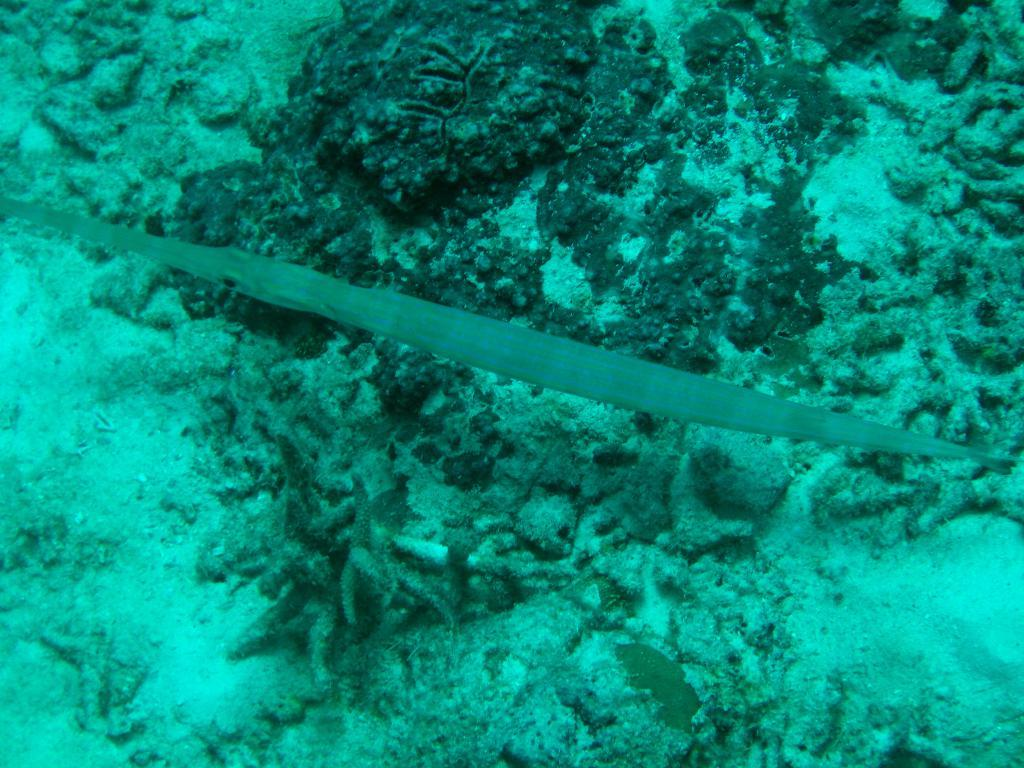What type of environment is shown in the image? The image depicts an underwater environment. Can you describe any specific features of the underwater environment? Unfortunately, the provided facts do not give any specific details about the underwater environment. Are there any living organisms visible in the image? The provided facts do not mention any living organisms in the image. What type of steam can be seen rising from the alley in the image? There is no alley or steam present in the image, as it depicts an underwater environment. 